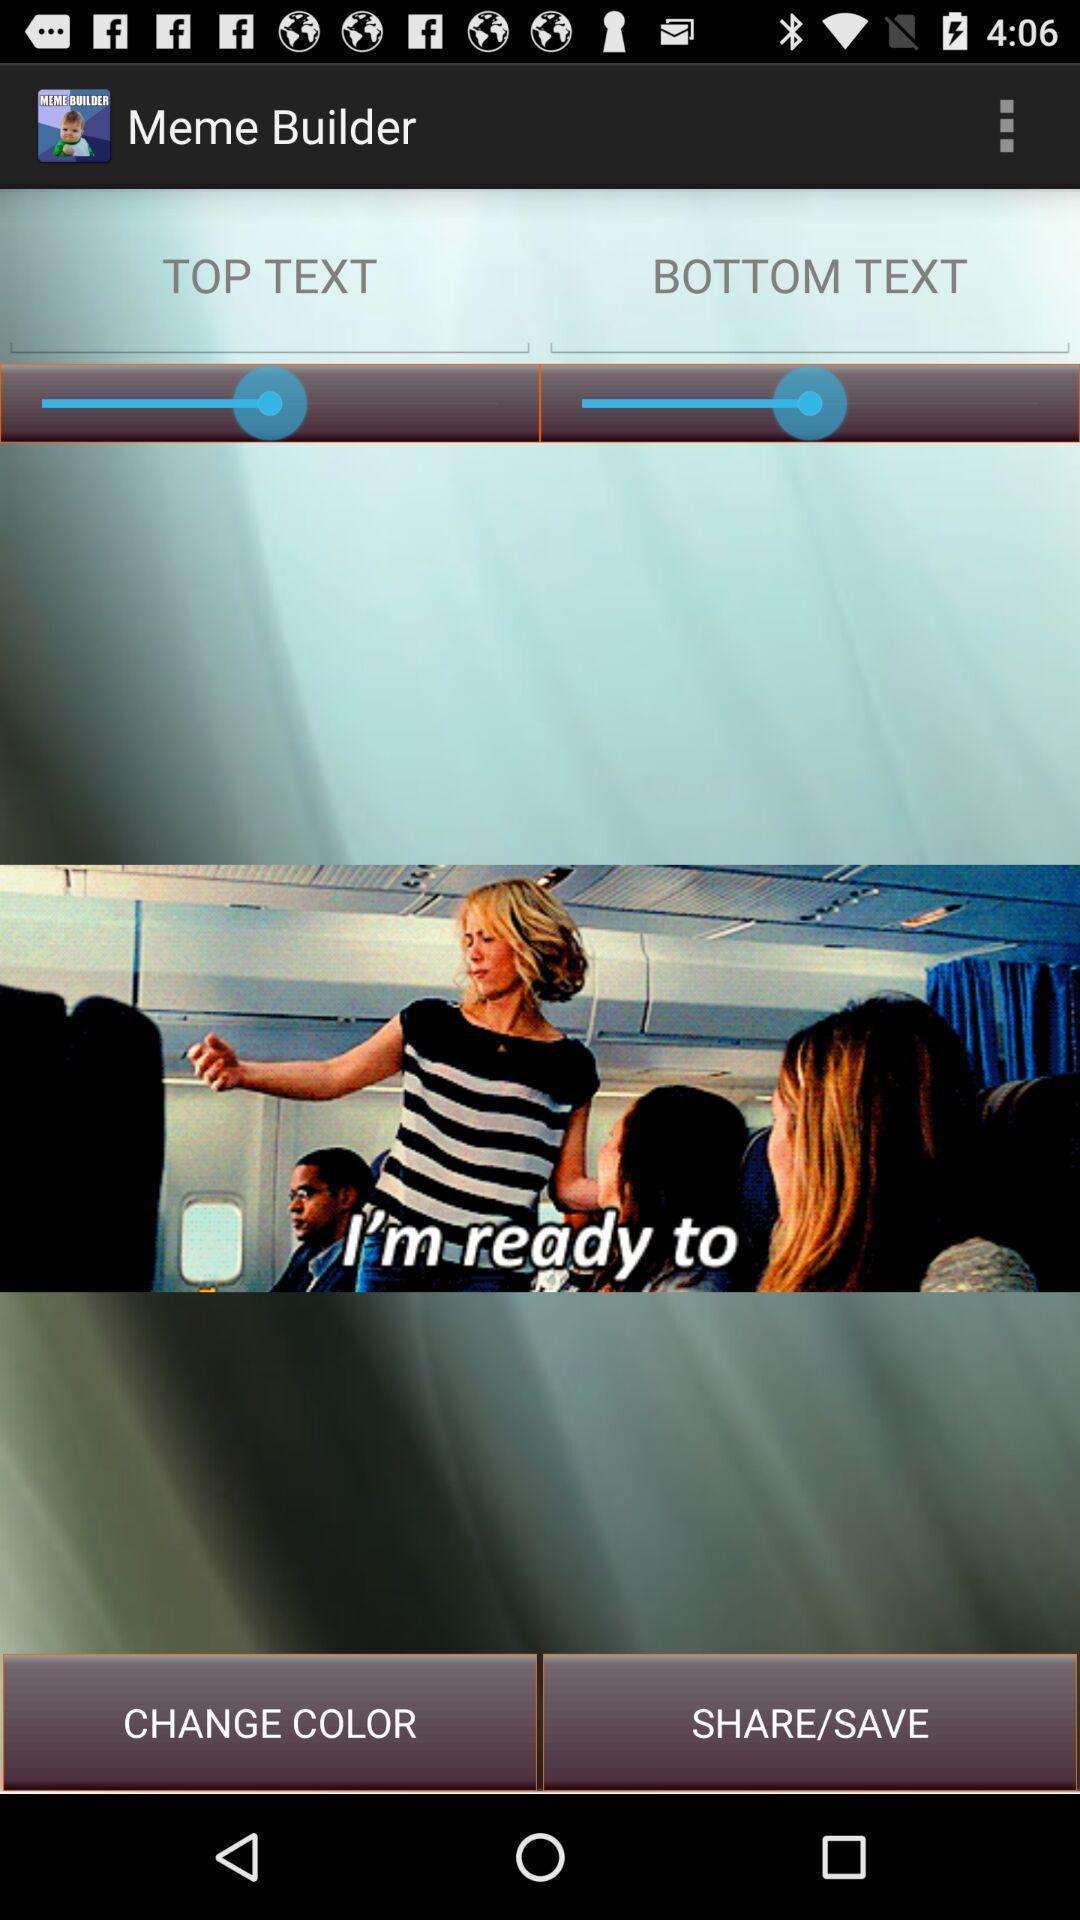Tell me what you see in this picture. Page displaying different options for editing. 